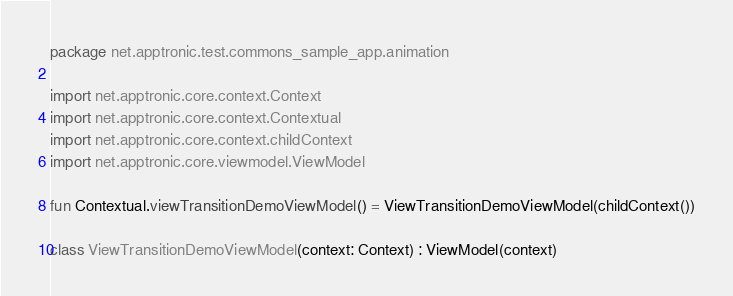Convert code to text. <code><loc_0><loc_0><loc_500><loc_500><_Kotlin_>package net.apptronic.test.commons_sample_app.animation

import net.apptronic.core.context.Context
import net.apptronic.core.context.Contextual
import net.apptronic.core.context.childContext
import net.apptronic.core.viewmodel.ViewModel

fun Contextual.viewTransitionDemoViewModel() = ViewTransitionDemoViewModel(childContext())

class ViewTransitionDemoViewModel(context: Context) : ViewModel(context)</code> 